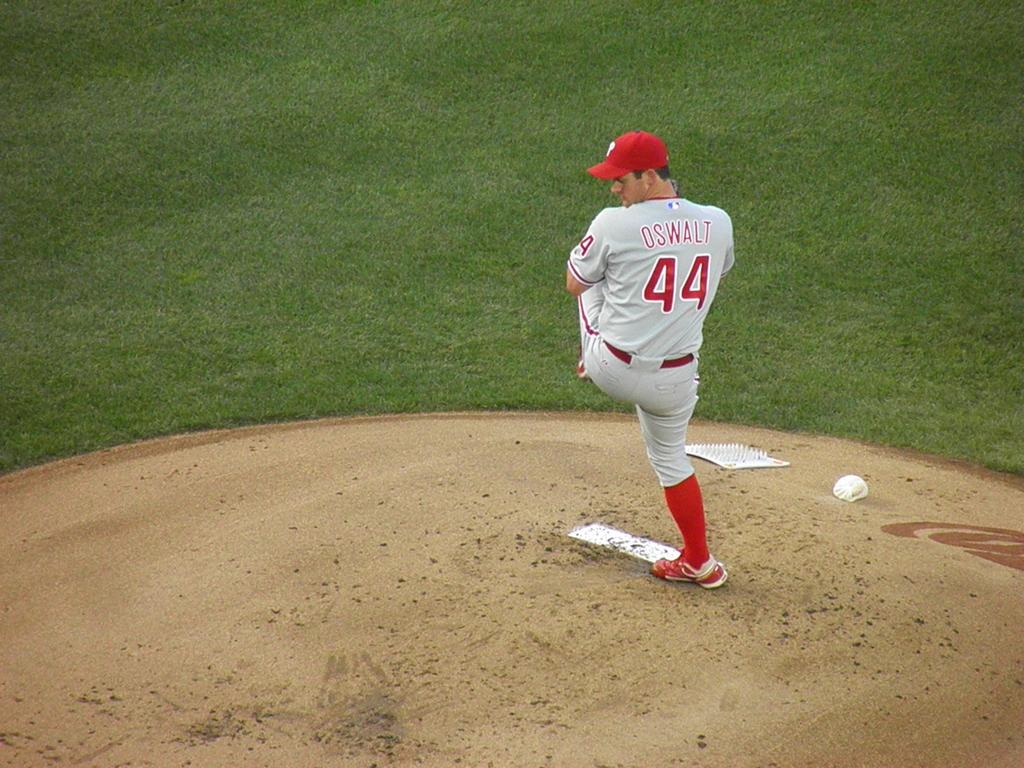<image>
Present a compact description of the photo's key features. The player on the mound is number 44, oswalt. 